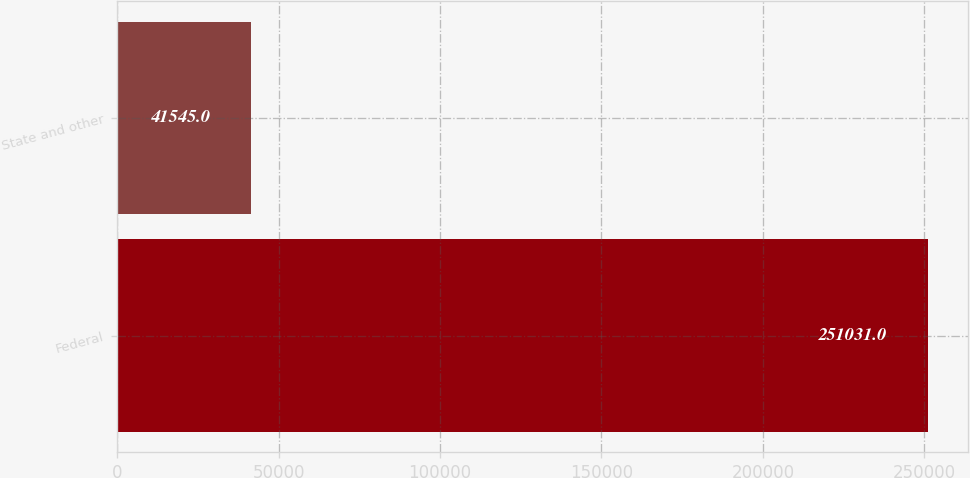Convert chart. <chart><loc_0><loc_0><loc_500><loc_500><bar_chart><fcel>Federal<fcel>State and other<nl><fcel>251031<fcel>41545<nl></chart> 